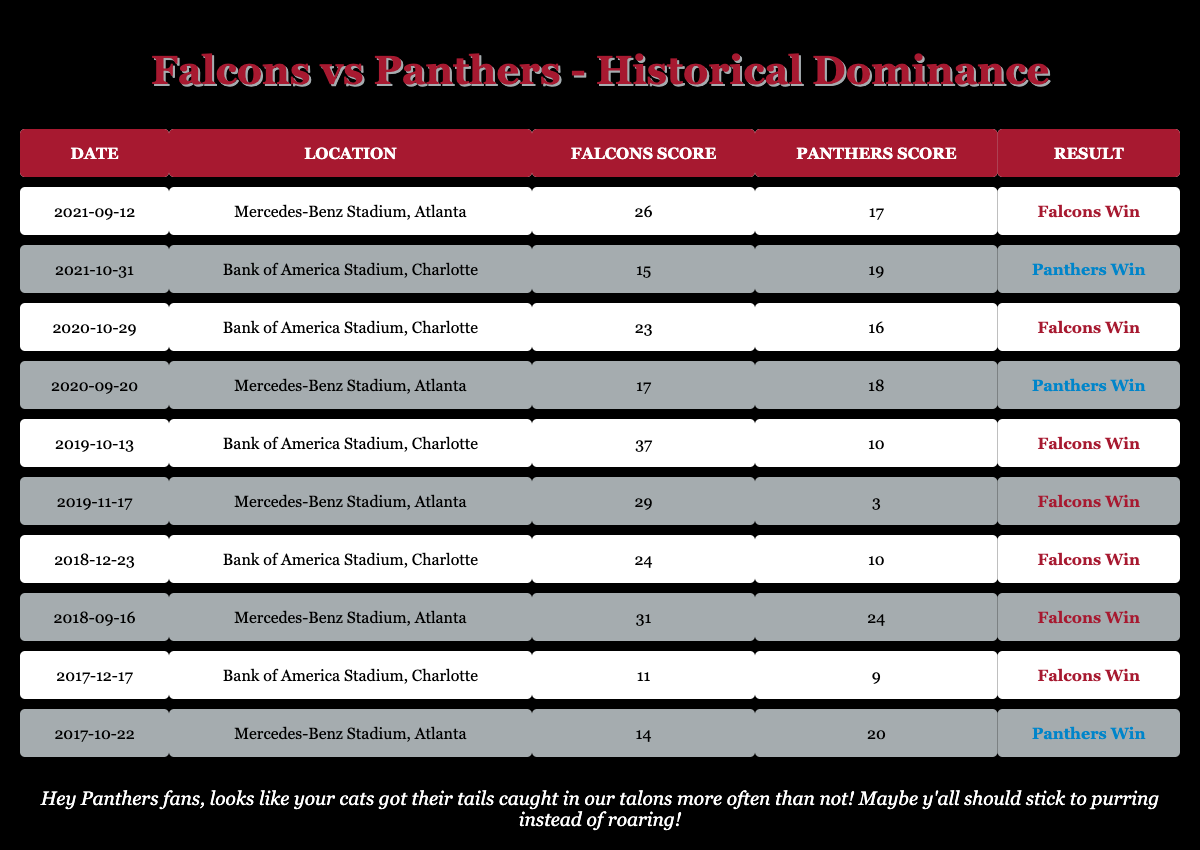What was the result of the game on September 12, 2021? The table indicates that on September 12, 2021, the Falcons played against the Panthers at Mercedes-Benz Stadium in Atlanta, where the Falcons scored 26 and the Panthers scored 17. The result was a win for the Falcons.
Answer: Falcons Win How many games did the Falcons win against the Panthers? By analyzing the results in the table, the Falcons won 6 out of the 10 games listed. This can be confirmed by counting the occurrences of "Falcons Win" in the result column.
Answer: 6 What was the average score of the Panthers in the games listed? To find the average score of the Panthers, we sum their scores: 17 + 19 + 16 + 18 + 10 + 3 + 10 + 24 + 9 + 20 =  126. There are 10 games, so the average is 126/10 = 12.6.
Answer: 12.6 Did the Falcons ever score more than 30 points against the Panthers? By checking the scores in the Falcons Score column, it can be seen that the highest score by the Falcons was 37. Since they scored 31 in another game, the answer is yes.
Answer: Yes Which location had the most Falcons wins? Upon reviewing the table, it can be observed that 5 of the Falcons wins occurred at “Mercedes-Benz Stadium, Atlanta” and 3 wins happened at “Bank of America Stadium, Charlotte." This indicates that Mercedes-Benz Stadium had the most Falcons wins against the Panthers.
Answer: Mercedes-Benz Stadium, Atlanta How many points did the Panthers score in their highest-scoring game against the Falcons? Looking through the scores listed for the Panthers, the highest score recorded was 24 points, specifically in the game on September 16, 2018.
Answer: 24 What was the total number of points scored by both teams in the game on October 31, 2021? The scores for the game on October 31, 2021, were 15 (Falcons) and 19 (Panthers). Adding these together (15 + 19) gives a total of 34 points scored in that game.
Answer: 34 In how many of the games listed did the Panthers win by more than one score (7 points or more)? The Panthers won two games by more than one score: the games on October 31, 2021, when they won by 4 points and on September 20, 2020, when they won by 1 point. No games had a 7-point margin or more. Thus, the count is 0.
Answer: 0 